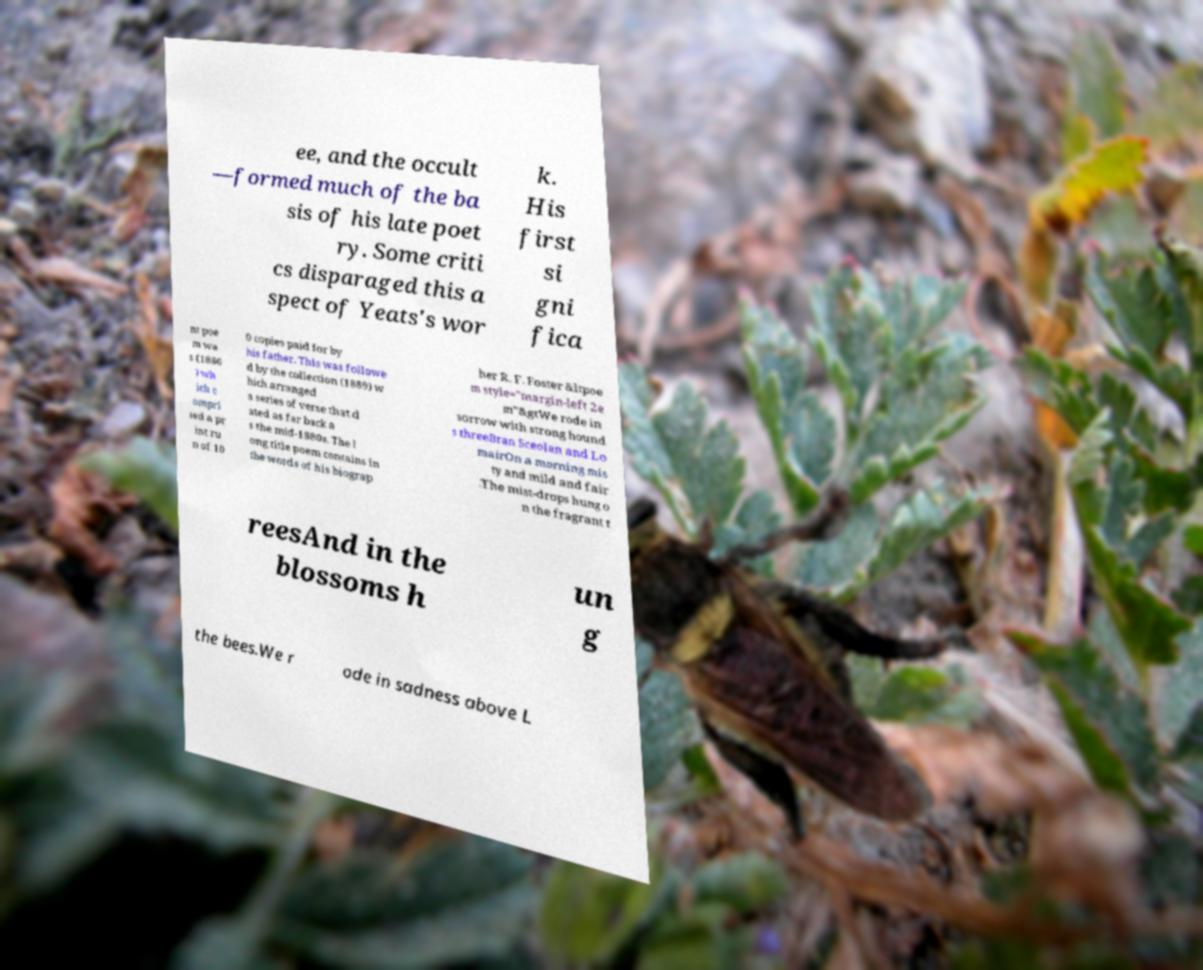Can you read and provide the text displayed in the image?This photo seems to have some interesting text. Can you extract and type it out for me? ee, and the occult —formed much of the ba sis of his late poet ry. Some criti cs disparaged this a spect of Yeats's wor k. His first si gni fica nt poe m wa s (1886 ) wh ich c ompri sed a pr int ru n of 10 0 copies paid for by his father. This was followe d by the collection (1889) w hich arranged a series of verse that d ated as far back a s the mid-1880s. The l ong title poem contains in the words of his biograp her R. F. Foster &ltpoe m style="margin-left 2e m"&gtWe rode in sorrow with strong hound s threeBran Sceolan and Lo mairOn a morning mis ty and mild and fair .The mist-drops hung o n the fragrant t reesAnd in the blossoms h un g the bees.We r ode in sadness above L 